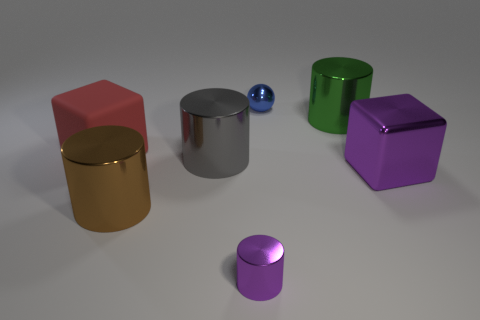Are there any other things that have the same material as the large red thing?
Your answer should be very brief. No. What is the size of the blue thing that is made of the same material as the large gray cylinder?
Keep it short and to the point. Small. Are there any tiny gray objects that have the same shape as the big gray metallic thing?
Make the answer very short. No. How many things are either tiny shiny cylinders to the left of the big metal block or small cyan cubes?
Make the answer very short. 1. What is the size of the object that is the same color as the large metallic cube?
Give a very brief answer. Small. There is a large block that is on the right side of the tiny blue sphere; is it the same color as the tiny object that is in front of the large green cylinder?
Provide a short and direct response. Yes. The sphere has what size?
Your answer should be compact. Small. How many large things are green cylinders or red things?
Your answer should be very brief. 2. What is the color of the matte thing that is the same size as the green metallic thing?
Keep it short and to the point. Red. What number of other objects are there of the same shape as the small purple object?
Provide a short and direct response. 3. 